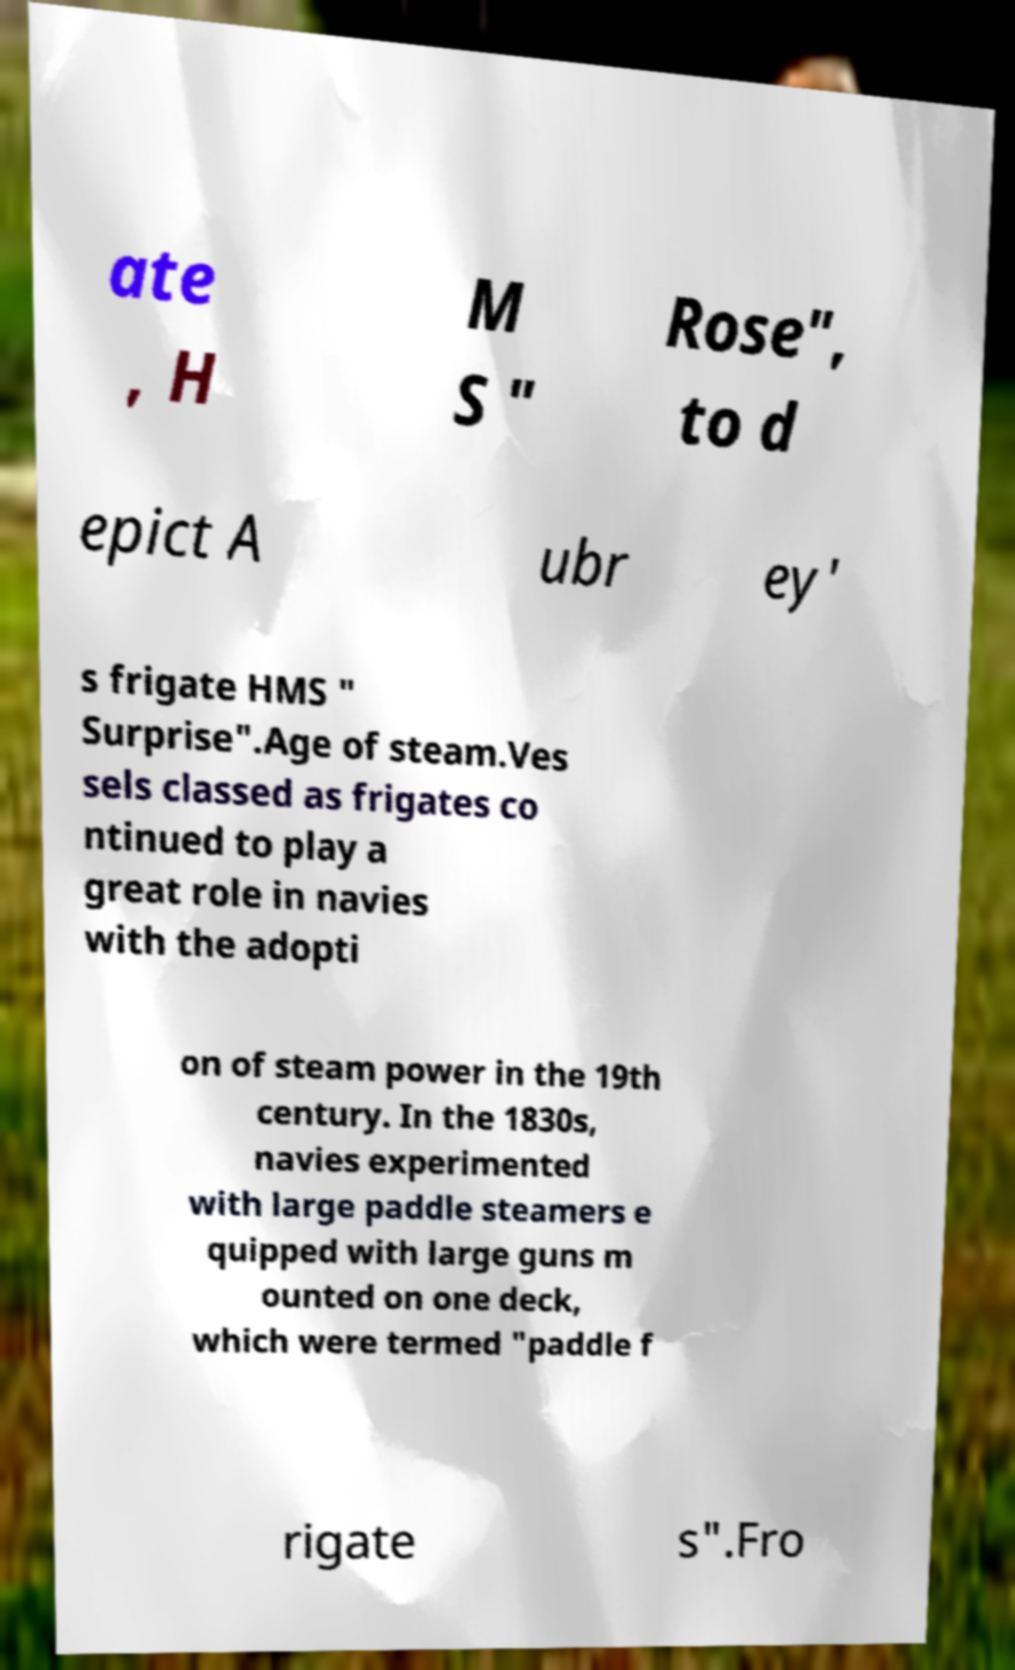Could you assist in decoding the text presented in this image and type it out clearly? ate , H M S " Rose", to d epict A ubr ey' s frigate HMS " Surprise".Age of steam.Ves sels classed as frigates co ntinued to play a great role in navies with the adopti on of steam power in the 19th century. In the 1830s, navies experimented with large paddle steamers e quipped with large guns m ounted on one deck, which were termed "paddle f rigate s".Fro 